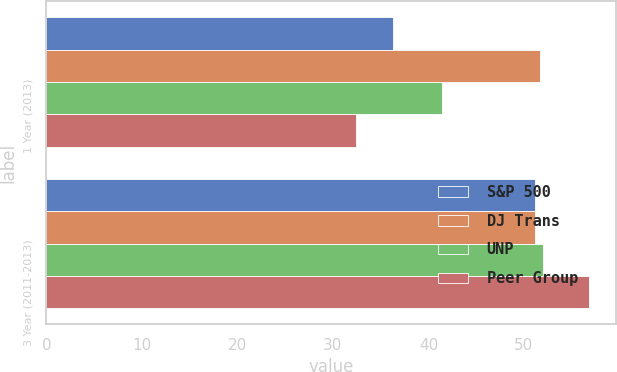Convert chart to OTSL. <chart><loc_0><loc_0><loc_500><loc_500><stacked_bar_chart><ecel><fcel>1 Year (2013)<fcel>3 Year (2011-2013)<nl><fcel>S&P 500<fcel>36.3<fcel>51.2<nl><fcel>DJ Trans<fcel>51.7<fcel>51.2<nl><fcel>UNP<fcel>41.4<fcel>52<nl><fcel>Peer Group<fcel>32.4<fcel>56.8<nl></chart> 